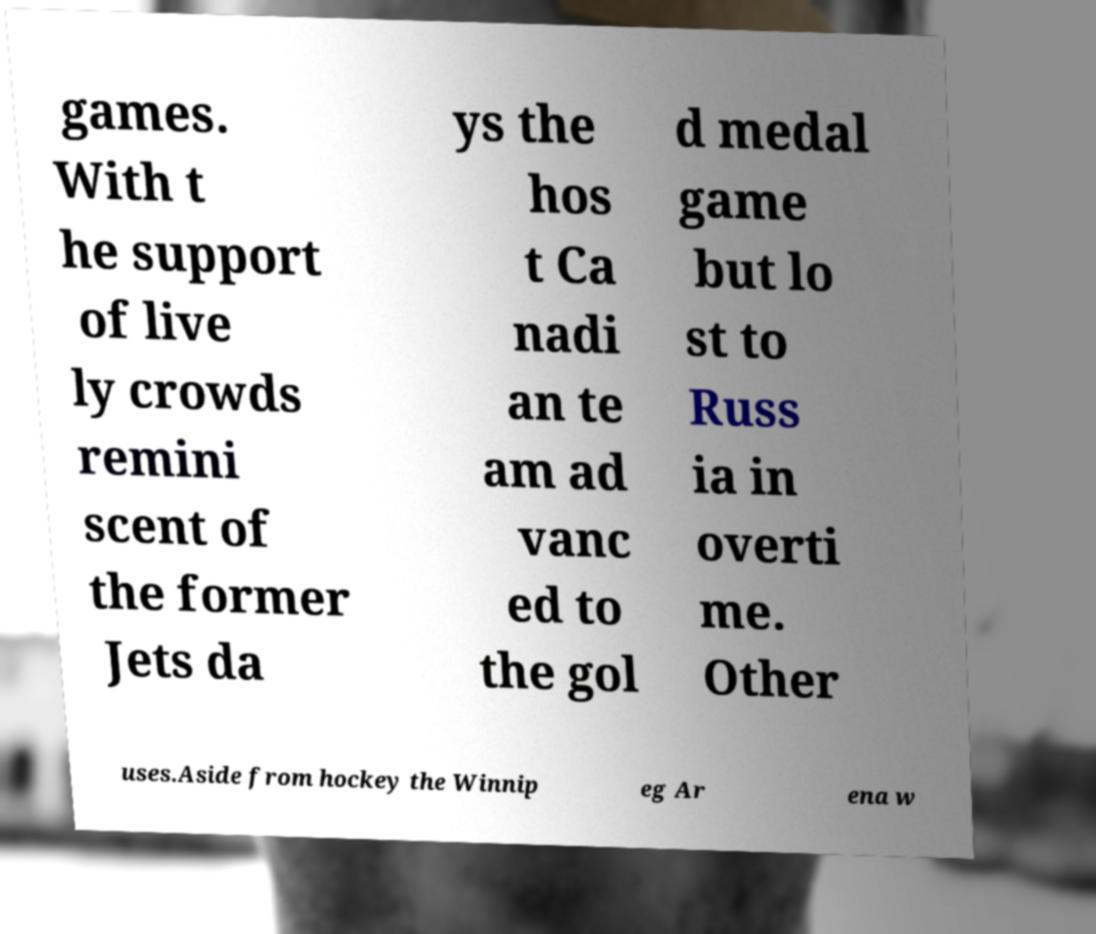Can you accurately transcribe the text from the provided image for me? games. With t he support of live ly crowds remini scent of the former Jets da ys the hos t Ca nadi an te am ad vanc ed to the gol d medal game but lo st to Russ ia in overti me. Other uses.Aside from hockey the Winnip eg Ar ena w 